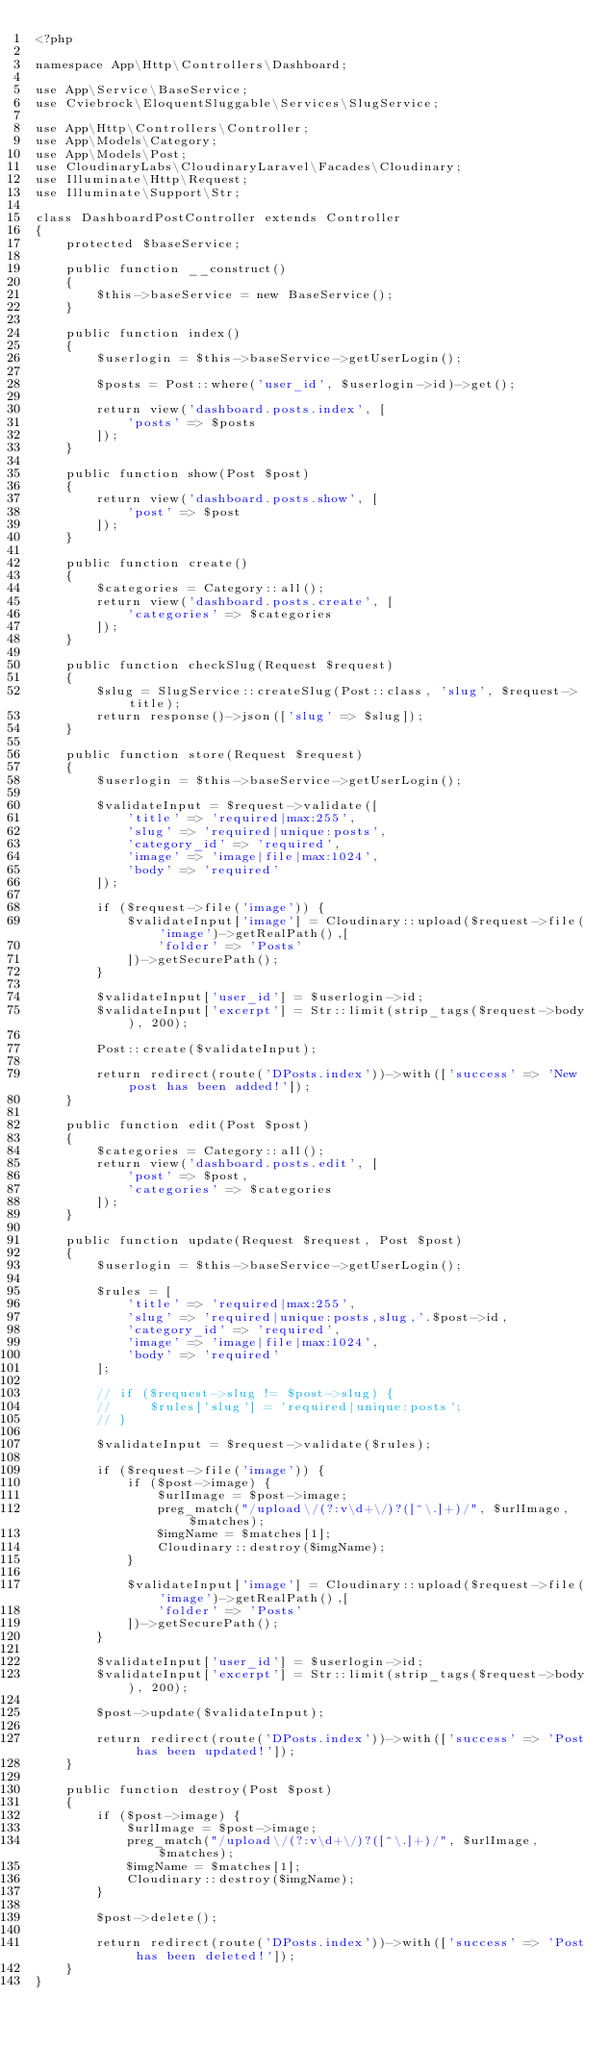Convert code to text. <code><loc_0><loc_0><loc_500><loc_500><_PHP_><?php

namespace App\Http\Controllers\Dashboard;

use App\Service\BaseService;
use Cviebrock\EloquentSluggable\Services\SlugService;

use App\Http\Controllers\Controller;
use App\Models\Category;
use App\Models\Post;
use CloudinaryLabs\CloudinaryLaravel\Facades\Cloudinary;
use Illuminate\Http\Request;
use Illuminate\Support\Str;

class DashboardPostController extends Controller
{
    protected $baseService;

    public function __construct()
    {
        $this->baseService = new BaseService();
    }

    public function index()
    {
        $userlogin = $this->baseService->getUserLogin();

        $posts = Post::where('user_id', $userlogin->id)->get();

        return view('dashboard.posts.index', [
            'posts' => $posts
        ]);
    }

    public function show(Post $post)
    {
        return view('dashboard.posts.show', [
            'post' => $post
        ]);
    }
    
    public function create()
    {
        $categories = Category::all();
        return view('dashboard.posts.create', [
            'categories' => $categories
        ]);
    }

    public function checkSlug(Request $request)
    {
        $slug = SlugService::createSlug(Post::class, 'slug', $request->title);
        return response()->json(['slug' => $slug]);
    }

    public function store(Request $request)
    {
        $userlogin = $this->baseService->getUserLogin();

        $validateInput = $request->validate([
            'title' => 'required|max:255',
            'slug' => 'required|unique:posts',
            'category_id' => 'required',
            'image' => 'image|file|max:1024',
            'body' => 'required'
        ]);

        if ($request->file('image')) {
            $validateInput['image'] = Cloudinary::upload($request->file('image')->getRealPath(),[
                'folder' => 'Posts'
            ])->getSecurePath();
        }

        $validateInput['user_id'] = $userlogin->id;
        $validateInput['excerpt'] = Str::limit(strip_tags($request->body), 200);

        Post::create($validateInput);

        return redirect(route('DPosts.index'))->with(['success' => 'New post has been added!']);
    }

    public function edit(Post $post)
    {
        $categories = Category::all();
        return view('dashboard.posts.edit', [
            'post' => $post,
            'categories' => $categories
        ]);
    }

    public function update(Request $request, Post $post)
    {
        $userlogin = $this->baseService->getUserLogin();

        $rules = [
            'title' => 'required|max:255',
            'slug' => 'required|unique:posts,slug,'.$post->id,
            'category_id' => 'required',
            'image' => 'image|file|max:1024',
            'body' => 'required'
        ];

        // if ($request->slug != $post->slug) {
        //     $rules['slug'] = 'required|unique:posts';
        // }

        $validateInput = $request->validate($rules);

        if ($request->file('image')) {
            if ($post->image) {
                $urlImage = $post->image;
                preg_match("/upload\/(?:v\d+\/)?([^\.]+)/", $urlImage, $matches);
                $imgName = $matches[1];
                Cloudinary::destroy($imgName);
            }

            $validateInput['image'] = Cloudinary::upload($request->file('image')->getRealPath(),[
                'folder' => 'Posts'
            ])->getSecurePath();
        }

        $validateInput['user_id'] = $userlogin->id;
        $validateInput['excerpt'] = Str::limit(strip_tags($request->body), 200);

        $post->update($validateInput);

        return redirect(route('DPosts.index'))->with(['success' => 'Post has been updated!']);
    }

    public function destroy(Post $post)
    {
        if ($post->image) {
            $urlImage = $post->image;
            preg_match("/upload\/(?:v\d+\/)?([^\.]+)/", $urlImage, $matches);
            $imgName = $matches[1];
            Cloudinary::destroy($imgName);
        }
        
        $post->delete();

        return redirect(route('DPosts.index'))->with(['success' => 'Post has been deleted!']);
    }
}
</code> 